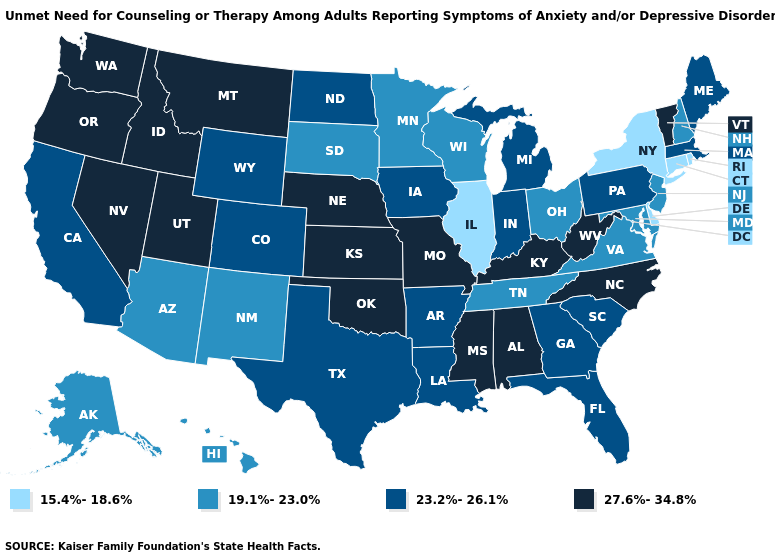Does the first symbol in the legend represent the smallest category?
Answer briefly. Yes. Name the states that have a value in the range 27.6%-34.8%?
Be succinct. Alabama, Idaho, Kansas, Kentucky, Mississippi, Missouri, Montana, Nebraska, Nevada, North Carolina, Oklahoma, Oregon, Utah, Vermont, Washington, West Virginia. Does Delaware have the lowest value in the South?
Write a very short answer. Yes. Name the states that have a value in the range 27.6%-34.8%?
Write a very short answer. Alabama, Idaho, Kansas, Kentucky, Mississippi, Missouri, Montana, Nebraska, Nevada, North Carolina, Oklahoma, Oregon, Utah, Vermont, Washington, West Virginia. Does New Mexico have the lowest value in the West?
Give a very brief answer. Yes. Among the states that border Wyoming , does Nebraska have the highest value?
Quick response, please. Yes. What is the lowest value in states that border Pennsylvania?
Be succinct. 15.4%-18.6%. Which states have the highest value in the USA?
Short answer required. Alabama, Idaho, Kansas, Kentucky, Mississippi, Missouri, Montana, Nebraska, Nevada, North Carolina, Oklahoma, Oregon, Utah, Vermont, Washington, West Virginia. Among the states that border Georgia , which have the highest value?
Concise answer only. Alabama, North Carolina. Name the states that have a value in the range 27.6%-34.8%?
Keep it brief. Alabama, Idaho, Kansas, Kentucky, Mississippi, Missouri, Montana, Nebraska, Nevada, North Carolina, Oklahoma, Oregon, Utah, Vermont, Washington, West Virginia. Among the states that border South Carolina , does North Carolina have the highest value?
Answer briefly. Yes. Name the states that have a value in the range 23.2%-26.1%?
Concise answer only. Arkansas, California, Colorado, Florida, Georgia, Indiana, Iowa, Louisiana, Maine, Massachusetts, Michigan, North Dakota, Pennsylvania, South Carolina, Texas, Wyoming. What is the lowest value in the Northeast?
Quick response, please. 15.4%-18.6%. Which states have the highest value in the USA?
Concise answer only. Alabama, Idaho, Kansas, Kentucky, Mississippi, Missouri, Montana, Nebraska, Nevada, North Carolina, Oklahoma, Oregon, Utah, Vermont, Washington, West Virginia. Is the legend a continuous bar?
Concise answer only. No. 